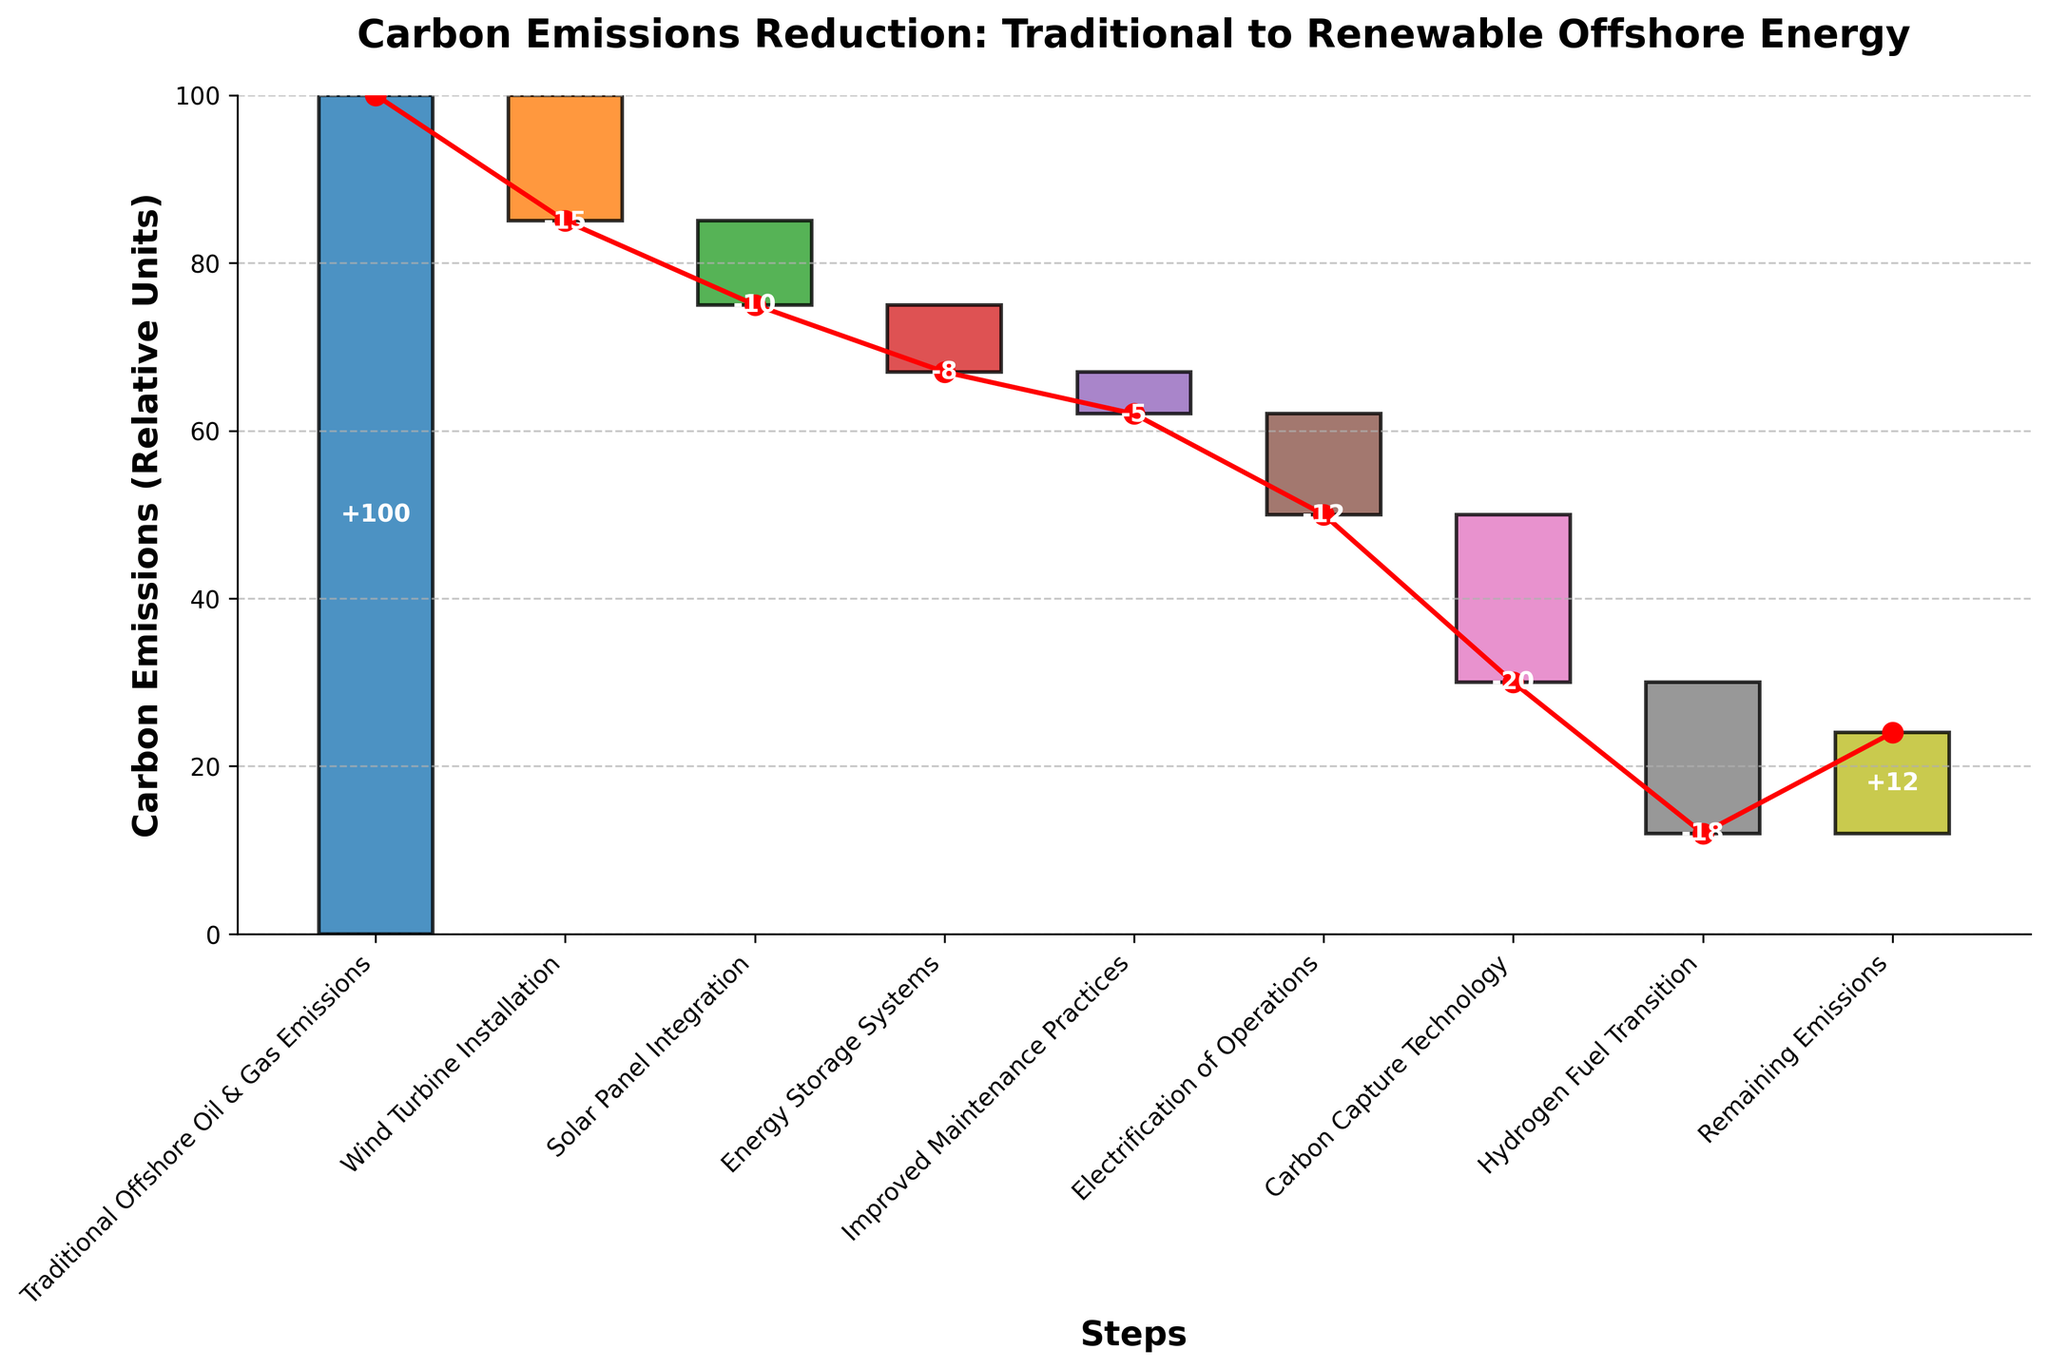What's the title of the chart? The title of the chart is displayed prominently at the top center of the figure. It reads "Carbon Emissions Reduction: Traditional to Renewable Offshore Energy".
Answer: Carbon Emissions Reduction: Traditional to Renewable Offshore Energy How many steps are illustrated in the chart? The chart has individual bars representing each step in emissions reduction. By counting the categories on the x-axis, we can see there are 9 steps.
Answer: 9 What is the final value of carbon emissions after all steps are considered? The final value is represented by the last bar in the waterfall chart labeled "Remaining Emissions," which is 12 units.
Answer: 12 Which step contributes the largest reduction in carbon emissions? By examining the heights of the bars, the step "Carbon Capture Technology" shows the largest single reduction, which is -20 units.
Answer: Carbon Capture Technology What are the cumulative carbon emissions after the "Solar Panel Integration" step? The cumulative emissions after a step can be found by looking up to that point on the net change line. Summing the values down to "Solar Panel Integration" (-15-10), the cumulative is 75 units.
Answer: 75 Compare the impact of "Hydrogen Fuel Transition" and "Electrification of Operations". Which one results in a greater reduction of carbon emissions? Looking at the bars for each step, "Electrification of Operations" reduces emissions by -12 units, while "Hydrogen Fuel Transition" reduces them by -18 units. Therefore, "Hydrogen Fuel Transition" has a greater impact.
Answer: Hydrogen Fuel Transition What is the sum of reductions from "Improved Maintenance Practices" and "Energy Storage Systems"? The bars labeled "Improved Maintenance Practices" and "Energy Storage Systems" show reductions of -5 and -8 units, respectively. Adding these together gives a total reduction of -13 units.
Answer: -13 Is the reduction in emissions consistent across all steps? To determine consistency, we observe the lengths of the reduction bars. Since the values vary widely, from -5 for "Improved Maintenance Practices" to -20 for "Carbon Capture Technology," the reductions are not consistent.
Answer: No What is the cumulative reduction up to "Electrification of Operations"? The cumulative reduction up to any step can be calculated incrementally. Starting from 100, the reduction up to "Electrification of Operations" (-15-10-8-5-12) results in a cumulative value of 50 units.
Answer: 50 How much greater is the reduction from "Carbon Capture Technology" compared to "Electrification of Operations"? "Carbon Capture Technology" contributes -20 units, while "Electrification of Operations" contributes -12 units. The difference is -20 - (-12) = -8 units. So, the reduction from "Carbon Capture Technology" is 8 units greater.
Answer: 8 